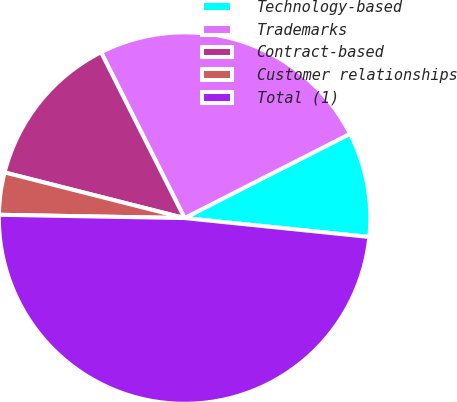<chart> <loc_0><loc_0><loc_500><loc_500><pie_chart><fcel>Technology-based<fcel>Trademarks<fcel>Contract-based<fcel>Customer relationships<fcel>Total (1)<nl><fcel>9.12%<fcel>24.93%<fcel>13.62%<fcel>3.67%<fcel>48.66%<nl></chart> 